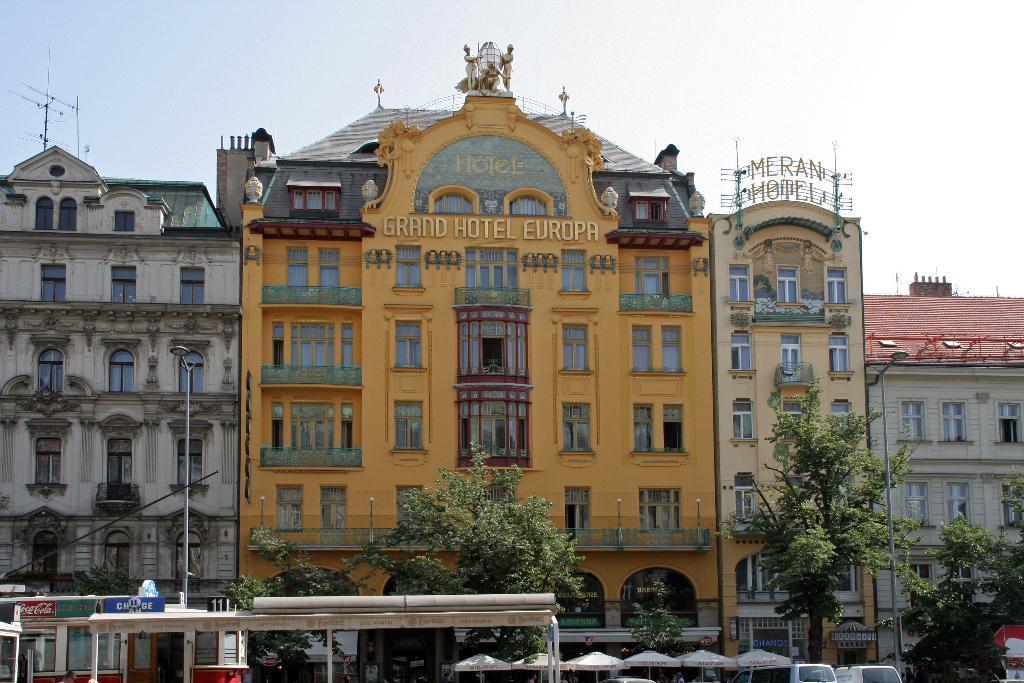Could you give a brief overview of what you see in this image? In this image I can see at the bottom there are umbrellas and trees. On the right side it looks like there are vehicles. In the middle there are buildings, at the top it is the sky. 